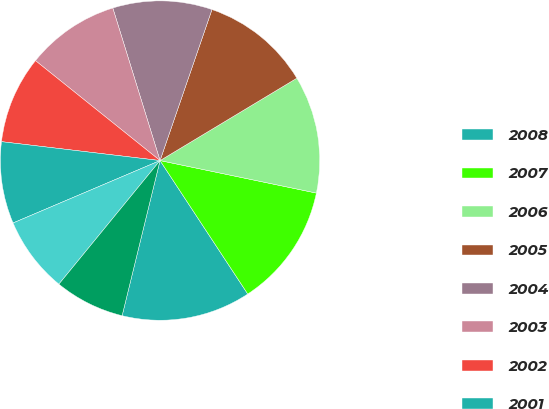Convert chart. <chart><loc_0><loc_0><loc_500><loc_500><pie_chart><fcel>2008<fcel>2007<fcel>2006<fcel>2005<fcel>2004<fcel>2003<fcel>2002<fcel>2001<fcel>2000<fcel>1999<nl><fcel>13.07%<fcel>12.48%<fcel>11.89%<fcel>11.1%<fcel>10.05%<fcel>9.46%<fcel>8.87%<fcel>8.28%<fcel>7.69%<fcel>7.1%<nl></chart> 